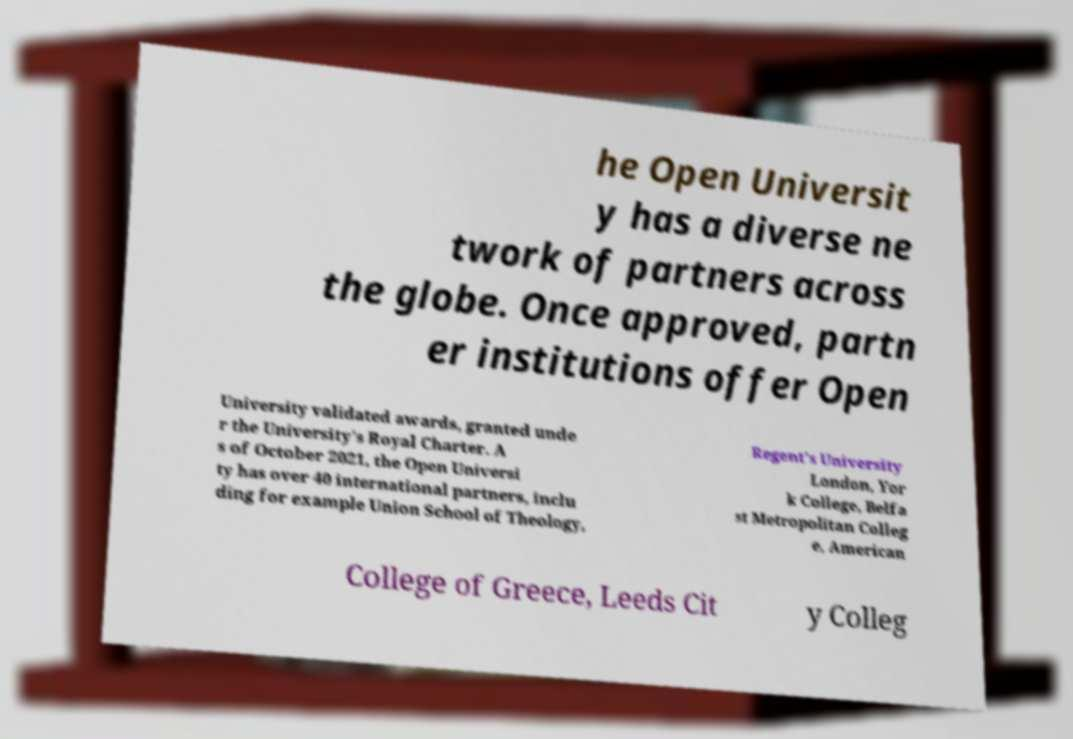Please read and relay the text visible in this image. What does it say? he Open Universit y has a diverse ne twork of partners across the globe. Once approved, partn er institutions offer Open University validated awards, granted unde r the University's Royal Charter. A s of October 2021, the Open Universi ty has over 40 international partners, inclu ding for example Union School of Theology, Regent's University London, Yor k College, Belfa st Metropolitan Colleg e, American College of Greece, Leeds Cit y Colleg 